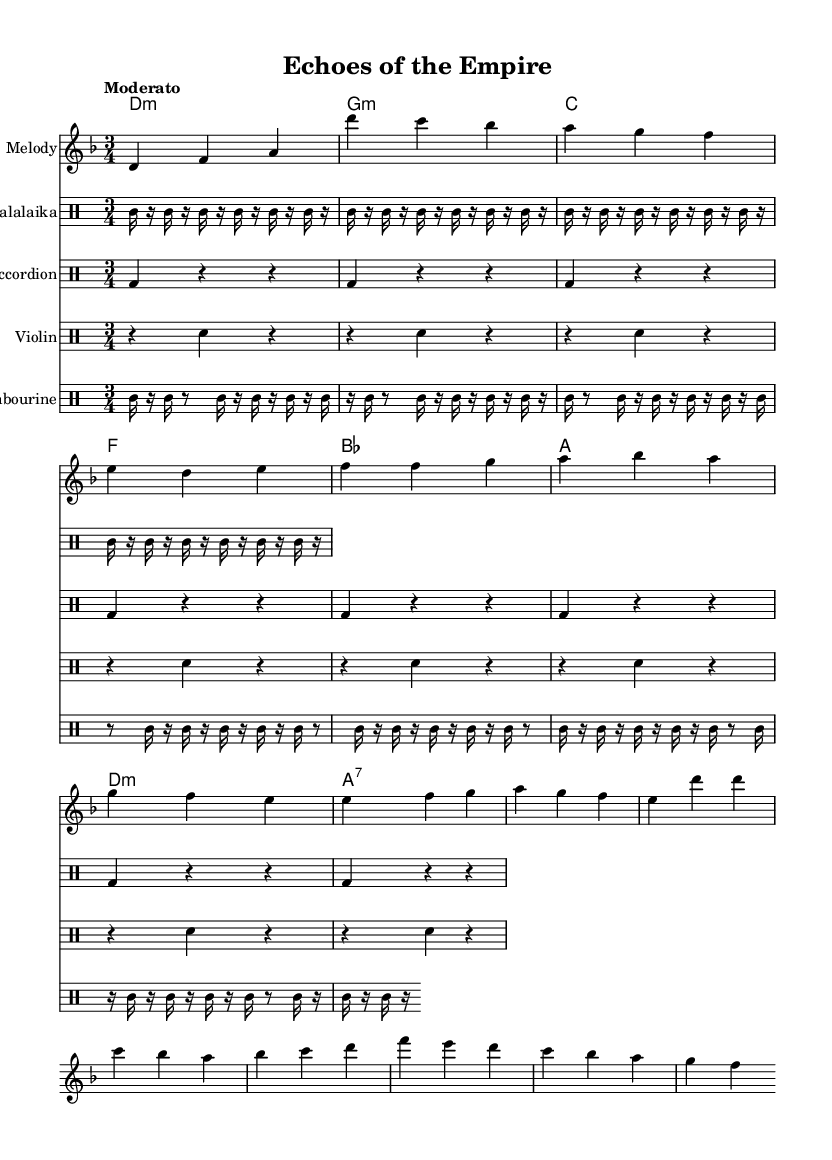What is the key signature of this music? The key signature is D minor, which includes one flat (B flat). This can be identified by looking at the key signature placed at the beginning of the staff.
Answer: D minor What is the time signature of this music? The time signature is 3/4, which indicates that there are three beats in each measure and a quarter note receives one beat. This is shown at the beginning of the score.
Answer: 3/4 What is the tempo marking of this piece? The tempo marking is "Moderato," which suggests a moderate speed for performing the piece. This marking is noted above the staff at the beginning of the score.
Answer: Moderato How many measures are present in the melody? The melody consists of 8 measures. By counting the individual sections of notes, it can be determined that there are 8 distinct groupings of notes, each separated by vertical bar lines.
Answer: 8 What instruments are represented in this score? The instruments represented in this score are balalaika, accordion, violin, and tambourine. These are mentioned in the instrument names displayed above each staff in the score.
Answer: Balalaika, accordion, violin, tambourine What type of musical form is demonstrated in the structure of this piece? The musical form is structured into an introduction, a verse, and a chorus, which can be inferred from the phrasing indicated within the melody. This reflects common forms found in folk music.
Answer: AABA Which drum pattern is associated with the balalaika? The drum pattern associated with the balalaika consists of a repeated rhythm played on the tom. It can be identified by the notations that specifically correspond to the "Balalaika" staff.
Answer: Tom 